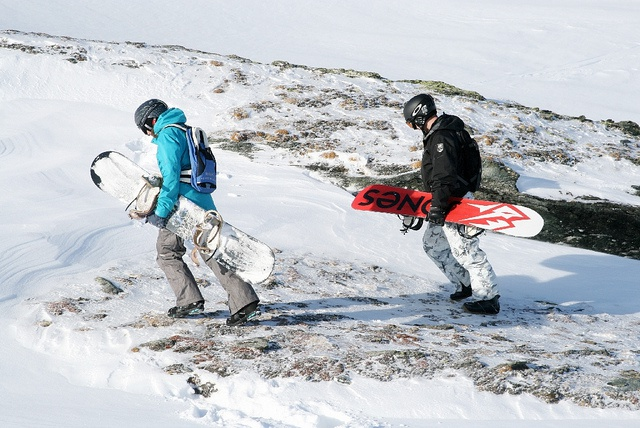Describe the objects in this image and their specific colors. I can see people in lightgray, darkgray, black, and gray tones, people in lightgray, black, darkgray, and gray tones, snowboard in lightgray, white, darkgray, gray, and black tones, snowboard in lightgray, white, salmon, black, and maroon tones, and backpack in lightgray, black, blue, and navy tones in this image. 